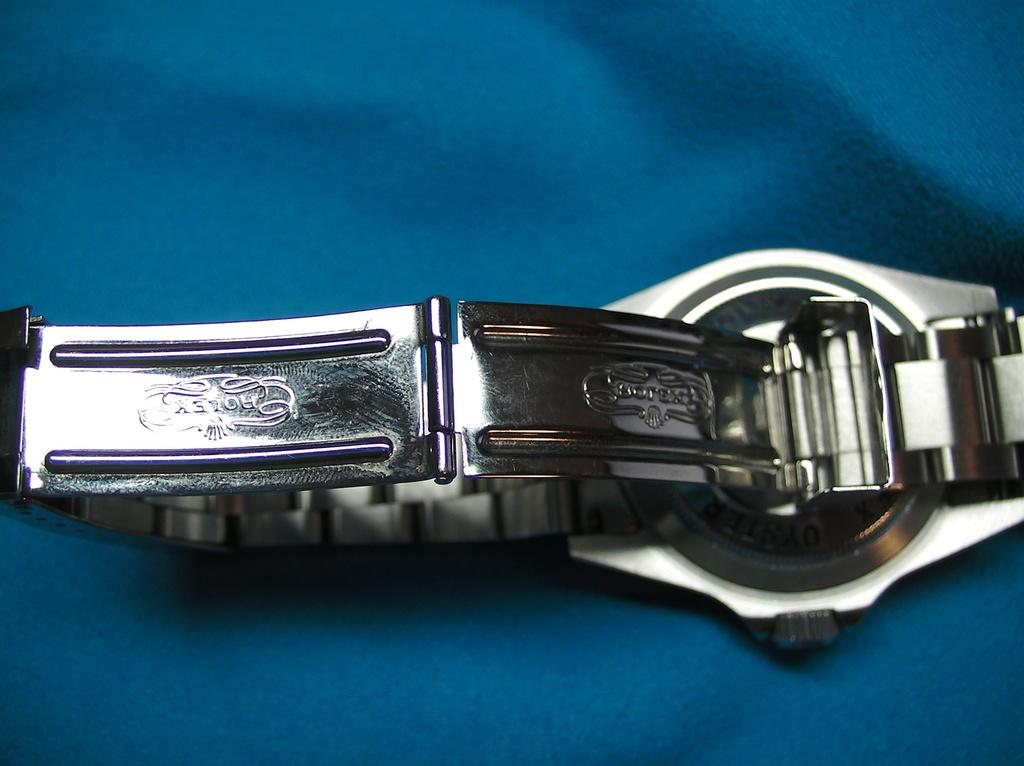What color is the cloth in the image? The cloth in the image is blue. What object is placed on the blue cloth? There is a wrist watch on the blue cloth. What material is the wrist watch made of? The wrist watch is made of steel. Where is the light source coming from in the image? There is no mention of a light source in the image, so it cannot be determined from the provided facts. 